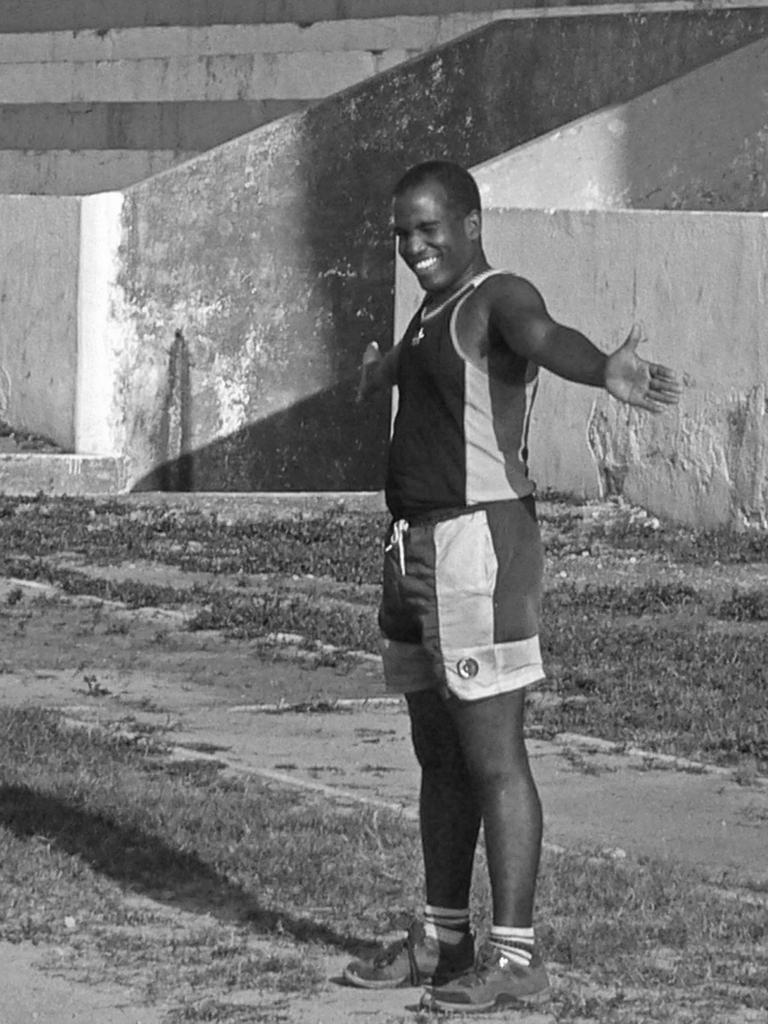What can be seen on the right side of the image? There is a person on the right side of the image. What is the person wearing? The person is wearing a shirt. What is the person doing in the image? The person is doing exercises. Where are the exercises being performed? The exercises are being performed on the ground. What type of vegetation is present on the ground? The ground has grass on it. What structures can be seen in the background of the image? There are two fences and a wall in the background of the image. What design can be seen on the stem of the plant in the image? There is no plant or stem present in the image; it features a person doing exercises on a grassy ground with a wall and fences in the background. 